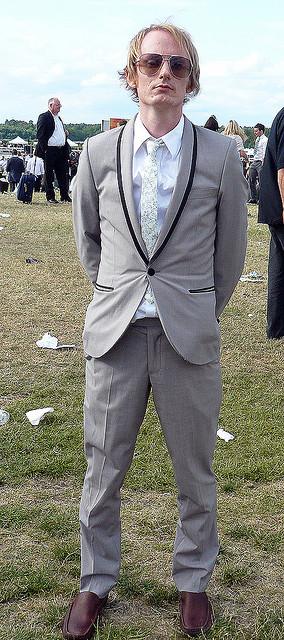What is this boy about to do?
Keep it brief. Smile. What does the pattern represent on the tie?
Quick response, please. Floral. Is this man formally dressed?
Be succinct. Yes. Are there people sitting down?
Keep it brief. No. Is the lawn crowded?
Give a very brief answer. Yes. Why the sunglasses?
Quick response, please. Sunny. Is it raining?
Concise answer only. No. What is these men's profession?
Concise answer only. Driver. Is the boy happy to be there?
Keep it brief. No. 